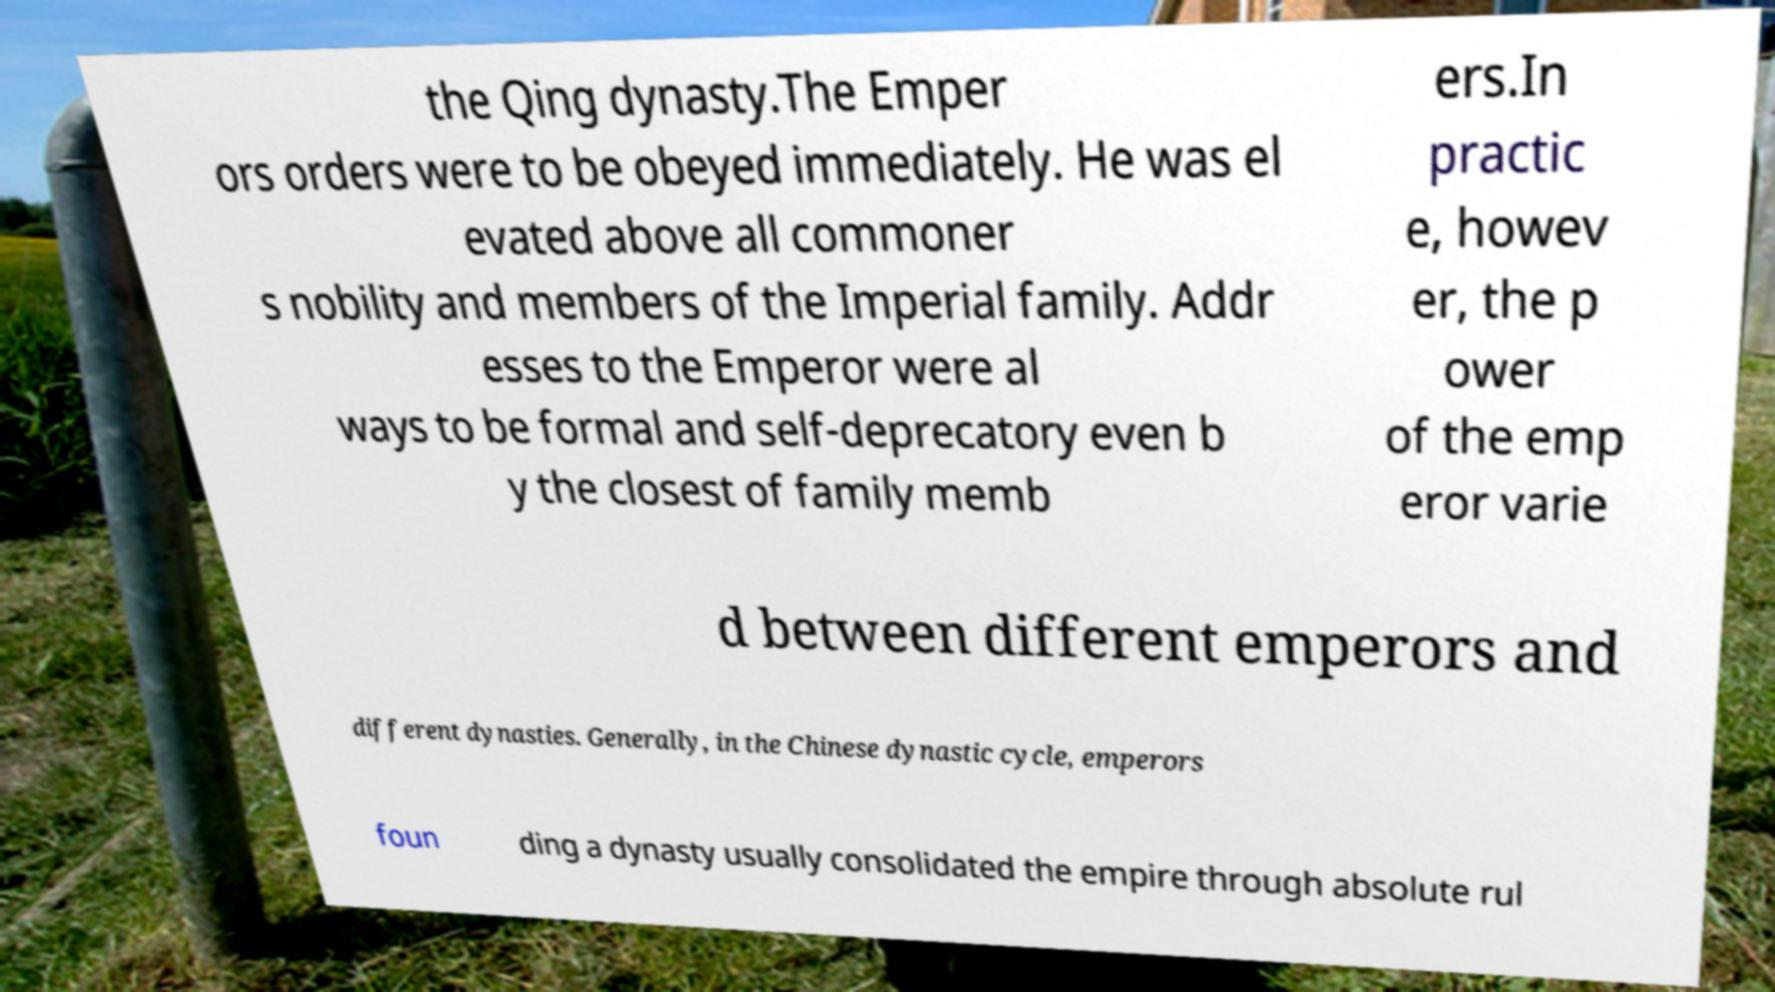Please identify and transcribe the text found in this image. the Qing dynasty.The Emper ors orders were to be obeyed immediately. He was el evated above all commoner s nobility and members of the Imperial family. Addr esses to the Emperor were al ways to be formal and self-deprecatory even b y the closest of family memb ers.In practic e, howev er, the p ower of the emp eror varie d between different emperors and different dynasties. Generally, in the Chinese dynastic cycle, emperors foun ding a dynasty usually consolidated the empire through absolute rul 